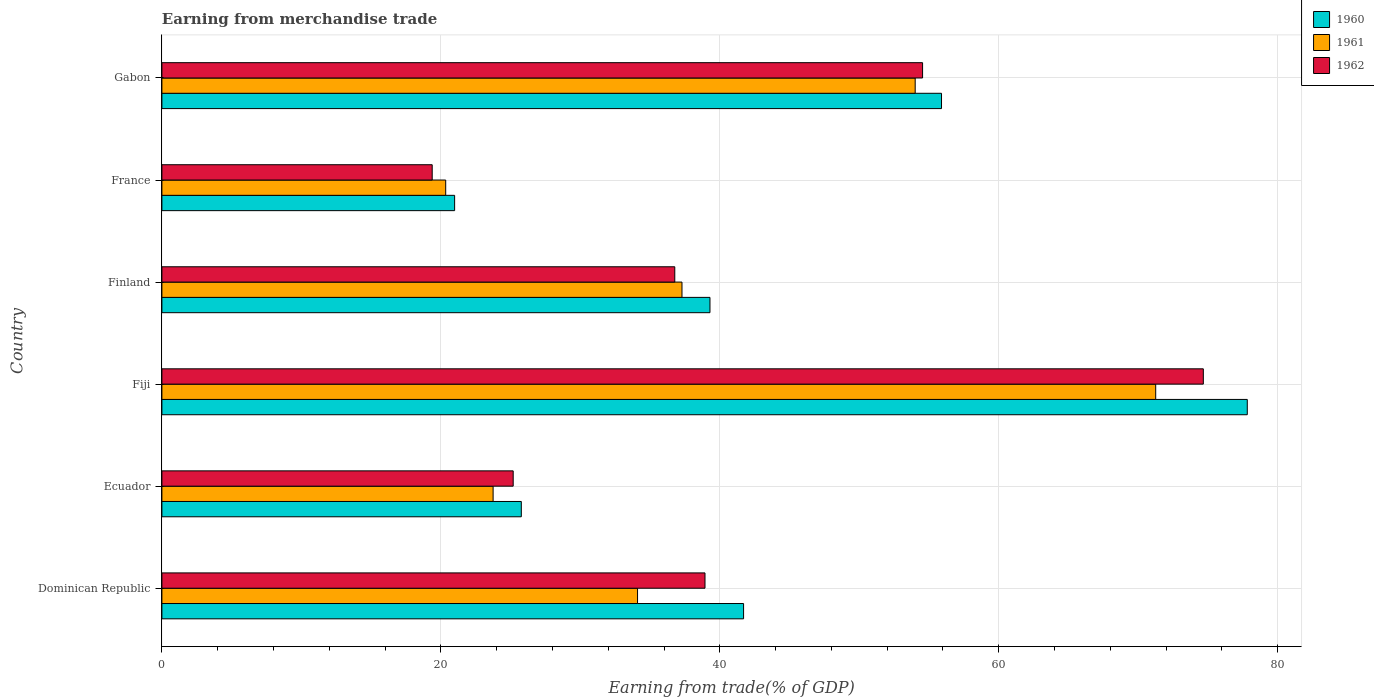How many groups of bars are there?
Your answer should be very brief. 6. Are the number of bars per tick equal to the number of legend labels?
Provide a succinct answer. Yes. How many bars are there on the 1st tick from the top?
Offer a very short reply. 3. What is the label of the 3rd group of bars from the top?
Make the answer very short. Finland. In how many cases, is the number of bars for a given country not equal to the number of legend labels?
Your answer should be very brief. 0. What is the earnings from trade in 1961 in Finland?
Make the answer very short. 37.29. Across all countries, what is the maximum earnings from trade in 1962?
Your answer should be compact. 74.67. Across all countries, what is the minimum earnings from trade in 1962?
Ensure brevity in your answer.  19.38. In which country was the earnings from trade in 1962 maximum?
Provide a short and direct response. Fiji. In which country was the earnings from trade in 1960 minimum?
Your answer should be compact. France. What is the total earnings from trade in 1961 in the graph?
Offer a very short reply. 240.75. What is the difference between the earnings from trade in 1961 in Fiji and that in France?
Give a very brief answer. 50.91. What is the difference between the earnings from trade in 1961 in Gabon and the earnings from trade in 1960 in France?
Ensure brevity in your answer.  33.02. What is the average earnings from trade in 1962 per country?
Make the answer very short. 41.58. What is the difference between the earnings from trade in 1962 and earnings from trade in 1960 in Fiji?
Keep it short and to the point. -3.15. What is the ratio of the earnings from trade in 1961 in Finland to that in France?
Your response must be concise. 1.83. Is the earnings from trade in 1961 in Dominican Republic less than that in Finland?
Ensure brevity in your answer.  Yes. Is the difference between the earnings from trade in 1962 in Fiji and France greater than the difference between the earnings from trade in 1960 in Fiji and France?
Give a very brief answer. No. What is the difference between the highest and the second highest earnings from trade in 1962?
Offer a very short reply. 20.13. What is the difference between the highest and the lowest earnings from trade in 1960?
Give a very brief answer. 56.83. In how many countries, is the earnings from trade in 1962 greater than the average earnings from trade in 1962 taken over all countries?
Your answer should be compact. 2. What does the 2nd bar from the top in Ecuador represents?
Ensure brevity in your answer.  1961. What does the 3rd bar from the bottom in Finland represents?
Your response must be concise. 1962. How many bars are there?
Give a very brief answer. 18. What is the difference between two consecutive major ticks on the X-axis?
Provide a succinct answer. 20. Are the values on the major ticks of X-axis written in scientific E-notation?
Provide a succinct answer. No. Where does the legend appear in the graph?
Provide a succinct answer. Top right. How are the legend labels stacked?
Ensure brevity in your answer.  Vertical. What is the title of the graph?
Your response must be concise. Earning from merchandise trade. What is the label or title of the X-axis?
Give a very brief answer. Earning from trade(% of GDP). What is the label or title of the Y-axis?
Your response must be concise. Country. What is the Earning from trade(% of GDP) in 1960 in Dominican Republic?
Ensure brevity in your answer.  41.7. What is the Earning from trade(% of GDP) in 1961 in Dominican Republic?
Your answer should be very brief. 34.1. What is the Earning from trade(% of GDP) in 1962 in Dominican Republic?
Your answer should be very brief. 38.94. What is the Earning from trade(% of GDP) in 1960 in Ecuador?
Ensure brevity in your answer.  25.77. What is the Earning from trade(% of GDP) of 1961 in Ecuador?
Provide a succinct answer. 23.75. What is the Earning from trade(% of GDP) in 1962 in Ecuador?
Your answer should be very brief. 25.19. What is the Earning from trade(% of GDP) in 1960 in Fiji?
Provide a succinct answer. 77.82. What is the Earning from trade(% of GDP) of 1961 in Fiji?
Make the answer very short. 71.25. What is the Earning from trade(% of GDP) in 1962 in Fiji?
Ensure brevity in your answer.  74.67. What is the Earning from trade(% of GDP) in 1960 in Finland?
Your answer should be very brief. 39.29. What is the Earning from trade(% of GDP) in 1961 in Finland?
Give a very brief answer. 37.29. What is the Earning from trade(% of GDP) of 1962 in Finland?
Give a very brief answer. 36.77. What is the Earning from trade(% of GDP) of 1960 in France?
Your response must be concise. 20.99. What is the Earning from trade(% of GDP) of 1961 in France?
Provide a short and direct response. 20.35. What is the Earning from trade(% of GDP) in 1962 in France?
Keep it short and to the point. 19.38. What is the Earning from trade(% of GDP) in 1960 in Gabon?
Your response must be concise. 55.9. What is the Earning from trade(% of GDP) in 1961 in Gabon?
Keep it short and to the point. 54.01. What is the Earning from trade(% of GDP) of 1962 in Gabon?
Ensure brevity in your answer.  54.54. Across all countries, what is the maximum Earning from trade(% of GDP) of 1960?
Your answer should be very brief. 77.82. Across all countries, what is the maximum Earning from trade(% of GDP) of 1961?
Your response must be concise. 71.25. Across all countries, what is the maximum Earning from trade(% of GDP) of 1962?
Provide a succinct answer. 74.67. Across all countries, what is the minimum Earning from trade(% of GDP) in 1960?
Ensure brevity in your answer.  20.99. Across all countries, what is the minimum Earning from trade(% of GDP) of 1961?
Keep it short and to the point. 20.35. Across all countries, what is the minimum Earning from trade(% of GDP) in 1962?
Give a very brief answer. 19.38. What is the total Earning from trade(% of GDP) in 1960 in the graph?
Ensure brevity in your answer.  261.47. What is the total Earning from trade(% of GDP) in 1961 in the graph?
Offer a very short reply. 240.75. What is the total Earning from trade(% of GDP) of 1962 in the graph?
Ensure brevity in your answer.  249.48. What is the difference between the Earning from trade(% of GDP) in 1960 in Dominican Republic and that in Ecuador?
Your answer should be very brief. 15.94. What is the difference between the Earning from trade(% of GDP) in 1961 in Dominican Republic and that in Ecuador?
Provide a succinct answer. 10.36. What is the difference between the Earning from trade(% of GDP) of 1962 in Dominican Republic and that in Ecuador?
Your response must be concise. 13.75. What is the difference between the Earning from trade(% of GDP) in 1960 in Dominican Republic and that in Fiji?
Make the answer very short. -36.12. What is the difference between the Earning from trade(% of GDP) in 1961 in Dominican Republic and that in Fiji?
Provide a short and direct response. -37.15. What is the difference between the Earning from trade(% of GDP) of 1962 in Dominican Republic and that in Fiji?
Make the answer very short. -35.73. What is the difference between the Earning from trade(% of GDP) of 1960 in Dominican Republic and that in Finland?
Your answer should be very brief. 2.41. What is the difference between the Earning from trade(% of GDP) of 1961 in Dominican Republic and that in Finland?
Offer a terse response. -3.19. What is the difference between the Earning from trade(% of GDP) in 1962 in Dominican Republic and that in Finland?
Offer a terse response. 2.17. What is the difference between the Earning from trade(% of GDP) in 1960 in Dominican Republic and that in France?
Give a very brief answer. 20.72. What is the difference between the Earning from trade(% of GDP) of 1961 in Dominican Republic and that in France?
Keep it short and to the point. 13.76. What is the difference between the Earning from trade(% of GDP) in 1962 in Dominican Republic and that in France?
Keep it short and to the point. 19.56. What is the difference between the Earning from trade(% of GDP) of 1960 in Dominican Republic and that in Gabon?
Ensure brevity in your answer.  -14.19. What is the difference between the Earning from trade(% of GDP) in 1961 in Dominican Republic and that in Gabon?
Offer a terse response. -19.91. What is the difference between the Earning from trade(% of GDP) in 1962 in Dominican Republic and that in Gabon?
Offer a terse response. -15.6. What is the difference between the Earning from trade(% of GDP) in 1960 in Ecuador and that in Fiji?
Provide a succinct answer. -52.05. What is the difference between the Earning from trade(% of GDP) in 1961 in Ecuador and that in Fiji?
Provide a succinct answer. -47.51. What is the difference between the Earning from trade(% of GDP) of 1962 in Ecuador and that in Fiji?
Your answer should be compact. -49.48. What is the difference between the Earning from trade(% of GDP) of 1960 in Ecuador and that in Finland?
Your answer should be very brief. -13.53. What is the difference between the Earning from trade(% of GDP) of 1961 in Ecuador and that in Finland?
Make the answer very short. -13.54. What is the difference between the Earning from trade(% of GDP) of 1962 in Ecuador and that in Finland?
Keep it short and to the point. -11.59. What is the difference between the Earning from trade(% of GDP) of 1960 in Ecuador and that in France?
Make the answer very short. 4.78. What is the difference between the Earning from trade(% of GDP) in 1961 in Ecuador and that in France?
Your answer should be very brief. 3.4. What is the difference between the Earning from trade(% of GDP) of 1962 in Ecuador and that in France?
Give a very brief answer. 5.81. What is the difference between the Earning from trade(% of GDP) in 1960 in Ecuador and that in Gabon?
Keep it short and to the point. -30.13. What is the difference between the Earning from trade(% of GDP) of 1961 in Ecuador and that in Gabon?
Provide a short and direct response. -30.26. What is the difference between the Earning from trade(% of GDP) of 1962 in Ecuador and that in Gabon?
Provide a short and direct response. -29.35. What is the difference between the Earning from trade(% of GDP) of 1960 in Fiji and that in Finland?
Offer a very short reply. 38.52. What is the difference between the Earning from trade(% of GDP) of 1961 in Fiji and that in Finland?
Provide a succinct answer. 33.96. What is the difference between the Earning from trade(% of GDP) in 1962 in Fiji and that in Finland?
Your answer should be very brief. 37.9. What is the difference between the Earning from trade(% of GDP) in 1960 in Fiji and that in France?
Your answer should be very brief. 56.83. What is the difference between the Earning from trade(% of GDP) of 1961 in Fiji and that in France?
Provide a short and direct response. 50.91. What is the difference between the Earning from trade(% of GDP) in 1962 in Fiji and that in France?
Provide a succinct answer. 55.29. What is the difference between the Earning from trade(% of GDP) in 1960 in Fiji and that in Gabon?
Your response must be concise. 21.92. What is the difference between the Earning from trade(% of GDP) in 1961 in Fiji and that in Gabon?
Your answer should be compact. 17.24. What is the difference between the Earning from trade(% of GDP) of 1962 in Fiji and that in Gabon?
Ensure brevity in your answer.  20.13. What is the difference between the Earning from trade(% of GDP) in 1960 in Finland and that in France?
Your answer should be compact. 18.31. What is the difference between the Earning from trade(% of GDP) of 1961 in Finland and that in France?
Your response must be concise. 16.94. What is the difference between the Earning from trade(% of GDP) in 1962 in Finland and that in France?
Keep it short and to the point. 17.39. What is the difference between the Earning from trade(% of GDP) of 1960 in Finland and that in Gabon?
Make the answer very short. -16.6. What is the difference between the Earning from trade(% of GDP) of 1961 in Finland and that in Gabon?
Offer a very short reply. -16.72. What is the difference between the Earning from trade(% of GDP) in 1962 in Finland and that in Gabon?
Make the answer very short. -17.77. What is the difference between the Earning from trade(% of GDP) in 1960 in France and that in Gabon?
Make the answer very short. -34.91. What is the difference between the Earning from trade(% of GDP) in 1961 in France and that in Gabon?
Your answer should be compact. -33.66. What is the difference between the Earning from trade(% of GDP) of 1962 in France and that in Gabon?
Give a very brief answer. -35.16. What is the difference between the Earning from trade(% of GDP) in 1960 in Dominican Republic and the Earning from trade(% of GDP) in 1961 in Ecuador?
Keep it short and to the point. 17.96. What is the difference between the Earning from trade(% of GDP) in 1960 in Dominican Republic and the Earning from trade(% of GDP) in 1962 in Ecuador?
Your answer should be very brief. 16.52. What is the difference between the Earning from trade(% of GDP) in 1961 in Dominican Republic and the Earning from trade(% of GDP) in 1962 in Ecuador?
Provide a short and direct response. 8.92. What is the difference between the Earning from trade(% of GDP) of 1960 in Dominican Republic and the Earning from trade(% of GDP) of 1961 in Fiji?
Provide a short and direct response. -29.55. What is the difference between the Earning from trade(% of GDP) in 1960 in Dominican Republic and the Earning from trade(% of GDP) in 1962 in Fiji?
Provide a succinct answer. -32.96. What is the difference between the Earning from trade(% of GDP) in 1961 in Dominican Republic and the Earning from trade(% of GDP) in 1962 in Fiji?
Keep it short and to the point. -40.57. What is the difference between the Earning from trade(% of GDP) of 1960 in Dominican Republic and the Earning from trade(% of GDP) of 1961 in Finland?
Your answer should be very brief. 4.42. What is the difference between the Earning from trade(% of GDP) in 1960 in Dominican Republic and the Earning from trade(% of GDP) in 1962 in Finland?
Ensure brevity in your answer.  4.93. What is the difference between the Earning from trade(% of GDP) in 1961 in Dominican Republic and the Earning from trade(% of GDP) in 1962 in Finland?
Give a very brief answer. -2.67. What is the difference between the Earning from trade(% of GDP) in 1960 in Dominican Republic and the Earning from trade(% of GDP) in 1961 in France?
Ensure brevity in your answer.  21.36. What is the difference between the Earning from trade(% of GDP) in 1960 in Dominican Republic and the Earning from trade(% of GDP) in 1962 in France?
Ensure brevity in your answer.  22.32. What is the difference between the Earning from trade(% of GDP) of 1961 in Dominican Republic and the Earning from trade(% of GDP) of 1962 in France?
Your answer should be compact. 14.72. What is the difference between the Earning from trade(% of GDP) in 1960 in Dominican Republic and the Earning from trade(% of GDP) in 1961 in Gabon?
Your answer should be very brief. -12.3. What is the difference between the Earning from trade(% of GDP) of 1960 in Dominican Republic and the Earning from trade(% of GDP) of 1962 in Gabon?
Your answer should be compact. -12.83. What is the difference between the Earning from trade(% of GDP) of 1961 in Dominican Republic and the Earning from trade(% of GDP) of 1962 in Gabon?
Provide a short and direct response. -20.44. What is the difference between the Earning from trade(% of GDP) in 1960 in Ecuador and the Earning from trade(% of GDP) in 1961 in Fiji?
Give a very brief answer. -45.48. What is the difference between the Earning from trade(% of GDP) of 1960 in Ecuador and the Earning from trade(% of GDP) of 1962 in Fiji?
Provide a succinct answer. -48.9. What is the difference between the Earning from trade(% of GDP) of 1961 in Ecuador and the Earning from trade(% of GDP) of 1962 in Fiji?
Give a very brief answer. -50.92. What is the difference between the Earning from trade(% of GDP) in 1960 in Ecuador and the Earning from trade(% of GDP) in 1961 in Finland?
Keep it short and to the point. -11.52. What is the difference between the Earning from trade(% of GDP) in 1960 in Ecuador and the Earning from trade(% of GDP) in 1962 in Finland?
Provide a succinct answer. -11. What is the difference between the Earning from trade(% of GDP) of 1961 in Ecuador and the Earning from trade(% of GDP) of 1962 in Finland?
Give a very brief answer. -13.02. What is the difference between the Earning from trade(% of GDP) of 1960 in Ecuador and the Earning from trade(% of GDP) of 1961 in France?
Your response must be concise. 5.42. What is the difference between the Earning from trade(% of GDP) of 1960 in Ecuador and the Earning from trade(% of GDP) of 1962 in France?
Your answer should be very brief. 6.39. What is the difference between the Earning from trade(% of GDP) of 1961 in Ecuador and the Earning from trade(% of GDP) of 1962 in France?
Ensure brevity in your answer.  4.37. What is the difference between the Earning from trade(% of GDP) in 1960 in Ecuador and the Earning from trade(% of GDP) in 1961 in Gabon?
Your answer should be compact. -28.24. What is the difference between the Earning from trade(% of GDP) of 1960 in Ecuador and the Earning from trade(% of GDP) of 1962 in Gabon?
Your response must be concise. -28.77. What is the difference between the Earning from trade(% of GDP) of 1961 in Ecuador and the Earning from trade(% of GDP) of 1962 in Gabon?
Provide a succinct answer. -30.79. What is the difference between the Earning from trade(% of GDP) of 1960 in Fiji and the Earning from trade(% of GDP) of 1961 in Finland?
Offer a very short reply. 40.53. What is the difference between the Earning from trade(% of GDP) of 1960 in Fiji and the Earning from trade(% of GDP) of 1962 in Finland?
Your answer should be very brief. 41.05. What is the difference between the Earning from trade(% of GDP) of 1961 in Fiji and the Earning from trade(% of GDP) of 1962 in Finland?
Your answer should be very brief. 34.48. What is the difference between the Earning from trade(% of GDP) in 1960 in Fiji and the Earning from trade(% of GDP) in 1961 in France?
Provide a short and direct response. 57.47. What is the difference between the Earning from trade(% of GDP) of 1960 in Fiji and the Earning from trade(% of GDP) of 1962 in France?
Offer a terse response. 58.44. What is the difference between the Earning from trade(% of GDP) of 1961 in Fiji and the Earning from trade(% of GDP) of 1962 in France?
Offer a terse response. 51.87. What is the difference between the Earning from trade(% of GDP) in 1960 in Fiji and the Earning from trade(% of GDP) in 1961 in Gabon?
Offer a terse response. 23.81. What is the difference between the Earning from trade(% of GDP) of 1960 in Fiji and the Earning from trade(% of GDP) of 1962 in Gabon?
Make the answer very short. 23.28. What is the difference between the Earning from trade(% of GDP) in 1961 in Fiji and the Earning from trade(% of GDP) in 1962 in Gabon?
Your response must be concise. 16.71. What is the difference between the Earning from trade(% of GDP) in 1960 in Finland and the Earning from trade(% of GDP) in 1961 in France?
Offer a terse response. 18.95. What is the difference between the Earning from trade(% of GDP) of 1960 in Finland and the Earning from trade(% of GDP) of 1962 in France?
Provide a succinct answer. 19.91. What is the difference between the Earning from trade(% of GDP) of 1961 in Finland and the Earning from trade(% of GDP) of 1962 in France?
Your response must be concise. 17.91. What is the difference between the Earning from trade(% of GDP) of 1960 in Finland and the Earning from trade(% of GDP) of 1961 in Gabon?
Give a very brief answer. -14.71. What is the difference between the Earning from trade(% of GDP) in 1960 in Finland and the Earning from trade(% of GDP) in 1962 in Gabon?
Ensure brevity in your answer.  -15.24. What is the difference between the Earning from trade(% of GDP) in 1961 in Finland and the Earning from trade(% of GDP) in 1962 in Gabon?
Give a very brief answer. -17.25. What is the difference between the Earning from trade(% of GDP) of 1960 in France and the Earning from trade(% of GDP) of 1961 in Gabon?
Offer a terse response. -33.02. What is the difference between the Earning from trade(% of GDP) in 1960 in France and the Earning from trade(% of GDP) in 1962 in Gabon?
Make the answer very short. -33.55. What is the difference between the Earning from trade(% of GDP) in 1961 in France and the Earning from trade(% of GDP) in 1962 in Gabon?
Make the answer very short. -34.19. What is the average Earning from trade(% of GDP) of 1960 per country?
Offer a terse response. 43.58. What is the average Earning from trade(% of GDP) in 1961 per country?
Offer a very short reply. 40.12. What is the average Earning from trade(% of GDP) in 1962 per country?
Your response must be concise. 41.58. What is the difference between the Earning from trade(% of GDP) in 1960 and Earning from trade(% of GDP) in 1961 in Dominican Republic?
Keep it short and to the point. 7.6. What is the difference between the Earning from trade(% of GDP) of 1960 and Earning from trade(% of GDP) of 1962 in Dominican Republic?
Give a very brief answer. 2.77. What is the difference between the Earning from trade(% of GDP) of 1961 and Earning from trade(% of GDP) of 1962 in Dominican Republic?
Provide a succinct answer. -4.84. What is the difference between the Earning from trade(% of GDP) in 1960 and Earning from trade(% of GDP) in 1961 in Ecuador?
Your answer should be compact. 2.02. What is the difference between the Earning from trade(% of GDP) of 1960 and Earning from trade(% of GDP) of 1962 in Ecuador?
Offer a very short reply. 0.58. What is the difference between the Earning from trade(% of GDP) in 1961 and Earning from trade(% of GDP) in 1962 in Ecuador?
Offer a very short reply. -1.44. What is the difference between the Earning from trade(% of GDP) of 1960 and Earning from trade(% of GDP) of 1961 in Fiji?
Offer a very short reply. 6.57. What is the difference between the Earning from trade(% of GDP) of 1960 and Earning from trade(% of GDP) of 1962 in Fiji?
Give a very brief answer. 3.15. What is the difference between the Earning from trade(% of GDP) in 1961 and Earning from trade(% of GDP) in 1962 in Fiji?
Your response must be concise. -3.42. What is the difference between the Earning from trade(% of GDP) of 1960 and Earning from trade(% of GDP) of 1961 in Finland?
Your answer should be very brief. 2.01. What is the difference between the Earning from trade(% of GDP) of 1960 and Earning from trade(% of GDP) of 1962 in Finland?
Your answer should be compact. 2.52. What is the difference between the Earning from trade(% of GDP) in 1961 and Earning from trade(% of GDP) in 1962 in Finland?
Offer a very short reply. 0.52. What is the difference between the Earning from trade(% of GDP) in 1960 and Earning from trade(% of GDP) in 1961 in France?
Your response must be concise. 0.64. What is the difference between the Earning from trade(% of GDP) of 1960 and Earning from trade(% of GDP) of 1962 in France?
Keep it short and to the point. 1.61. What is the difference between the Earning from trade(% of GDP) in 1961 and Earning from trade(% of GDP) in 1962 in France?
Ensure brevity in your answer.  0.97. What is the difference between the Earning from trade(% of GDP) in 1960 and Earning from trade(% of GDP) in 1961 in Gabon?
Offer a terse response. 1.89. What is the difference between the Earning from trade(% of GDP) in 1960 and Earning from trade(% of GDP) in 1962 in Gabon?
Provide a succinct answer. 1.36. What is the difference between the Earning from trade(% of GDP) in 1961 and Earning from trade(% of GDP) in 1962 in Gabon?
Provide a short and direct response. -0.53. What is the ratio of the Earning from trade(% of GDP) of 1960 in Dominican Republic to that in Ecuador?
Provide a succinct answer. 1.62. What is the ratio of the Earning from trade(% of GDP) in 1961 in Dominican Republic to that in Ecuador?
Offer a terse response. 1.44. What is the ratio of the Earning from trade(% of GDP) of 1962 in Dominican Republic to that in Ecuador?
Offer a very short reply. 1.55. What is the ratio of the Earning from trade(% of GDP) in 1960 in Dominican Republic to that in Fiji?
Make the answer very short. 0.54. What is the ratio of the Earning from trade(% of GDP) of 1961 in Dominican Republic to that in Fiji?
Make the answer very short. 0.48. What is the ratio of the Earning from trade(% of GDP) of 1962 in Dominican Republic to that in Fiji?
Provide a succinct answer. 0.52. What is the ratio of the Earning from trade(% of GDP) in 1960 in Dominican Republic to that in Finland?
Your answer should be compact. 1.06. What is the ratio of the Earning from trade(% of GDP) of 1961 in Dominican Republic to that in Finland?
Your response must be concise. 0.91. What is the ratio of the Earning from trade(% of GDP) of 1962 in Dominican Republic to that in Finland?
Your answer should be very brief. 1.06. What is the ratio of the Earning from trade(% of GDP) of 1960 in Dominican Republic to that in France?
Make the answer very short. 1.99. What is the ratio of the Earning from trade(% of GDP) of 1961 in Dominican Republic to that in France?
Ensure brevity in your answer.  1.68. What is the ratio of the Earning from trade(% of GDP) of 1962 in Dominican Republic to that in France?
Keep it short and to the point. 2.01. What is the ratio of the Earning from trade(% of GDP) of 1960 in Dominican Republic to that in Gabon?
Your answer should be very brief. 0.75. What is the ratio of the Earning from trade(% of GDP) of 1961 in Dominican Republic to that in Gabon?
Keep it short and to the point. 0.63. What is the ratio of the Earning from trade(% of GDP) in 1962 in Dominican Republic to that in Gabon?
Provide a short and direct response. 0.71. What is the ratio of the Earning from trade(% of GDP) of 1960 in Ecuador to that in Fiji?
Offer a terse response. 0.33. What is the ratio of the Earning from trade(% of GDP) of 1962 in Ecuador to that in Fiji?
Ensure brevity in your answer.  0.34. What is the ratio of the Earning from trade(% of GDP) in 1960 in Ecuador to that in Finland?
Your response must be concise. 0.66. What is the ratio of the Earning from trade(% of GDP) of 1961 in Ecuador to that in Finland?
Your answer should be very brief. 0.64. What is the ratio of the Earning from trade(% of GDP) in 1962 in Ecuador to that in Finland?
Provide a succinct answer. 0.68. What is the ratio of the Earning from trade(% of GDP) of 1960 in Ecuador to that in France?
Ensure brevity in your answer.  1.23. What is the ratio of the Earning from trade(% of GDP) in 1961 in Ecuador to that in France?
Offer a terse response. 1.17. What is the ratio of the Earning from trade(% of GDP) of 1962 in Ecuador to that in France?
Make the answer very short. 1.3. What is the ratio of the Earning from trade(% of GDP) of 1960 in Ecuador to that in Gabon?
Offer a terse response. 0.46. What is the ratio of the Earning from trade(% of GDP) in 1961 in Ecuador to that in Gabon?
Offer a very short reply. 0.44. What is the ratio of the Earning from trade(% of GDP) of 1962 in Ecuador to that in Gabon?
Offer a terse response. 0.46. What is the ratio of the Earning from trade(% of GDP) of 1960 in Fiji to that in Finland?
Make the answer very short. 1.98. What is the ratio of the Earning from trade(% of GDP) of 1961 in Fiji to that in Finland?
Make the answer very short. 1.91. What is the ratio of the Earning from trade(% of GDP) in 1962 in Fiji to that in Finland?
Give a very brief answer. 2.03. What is the ratio of the Earning from trade(% of GDP) in 1960 in Fiji to that in France?
Ensure brevity in your answer.  3.71. What is the ratio of the Earning from trade(% of GDP) in 1961 in Fiji to that in France?
Offer a terse response. 3.5. What is the ratio of the Earning from trade(% of GDP) in 1962 in Fiji to that in France?
Your answer should be compact. 3.85. What is the ratio of the Earning from trade(% of GDP) in 1960 in Fiji to that in Gabon?
Ensure brevity in your answer.  1.39. What is the ratio of the Earning from trade(% of GDP) in 1961 in Fiji to that in Gabon?
Make the answer very short. 1.32. What is the ratio of the Earning from trade(% of GDP) in 1962 in Fiji to that in Gabon?
Provide a short and direct response. 1.37. What is the ratio of the Earning from trade(% of GDP) in 1960 in Finland to that in France?
Your response must be concise. 1.87. What is the ratio of the Earning from trade(% of GDP) in 1961 in Finland to that in France?
Keep it short and to the point. 1.83. What is the ratio of the Earning from trade(% of GDP) of 1962 in Finland to that in France?
Your response must be concise. 1.9. What is the ratio of the Earning from trade(% of GDP) of 1960 in Finland to that in Gabon?
Your answer should be very brief. 0.7. What is the ratio of the Earning from trade(% of GDP) of 1961 in Finland to that in Gabon?
Keep it short and to the point. 0.69. What is the ratio of the Earning from trade(% of GDP) of 1962 in Finland to that in Gabon?
Your response must be concise. 0.67. What is the ratio of the Earning from trade(% of GDP) in 1960 in France to that in Gabon?
Your answer should be very brief. 0.38. What is the ratio of the Earning from trade(% of GDP) of 1961 in France to that in Gabon?
Ensure brevity in your answer.  0.38. What is the ratio of the Earning from trade(% of GDP) of 1962 in France to that in Gabon?
Your response must be concise. 0.36. What is the difference between the highest and the second highest Earning from trade(% of GDP) of 1960?
Give a very brief answer. 21.92. What is the difference between the highest and the second highest Earning from trade(% of GDP) of 1961?
Offer a very short reply. 17.24. What is the difference between the highest and the second highest Earning from trade(% of GDP) of 1962?
Keep it short and to the point. 20.13. What is the difference between the highest and the lowest Earning from trade(% of GDP) in 1960?
Provide a succinct answer. 56.83. What is the difference between the highest and the lowest Earning from trade(% of GDP) in 1961?
Ensure brevity in your answer.  50.91. What is the difference between the highest and the lowest Earning from trade(% of GDP) in 1962?
Offer a very short reply. 55.29. 